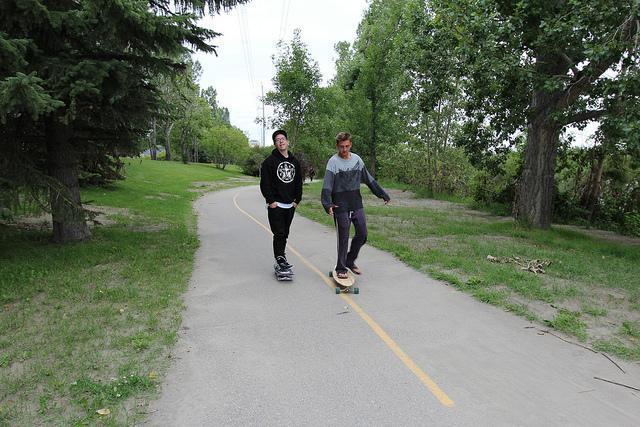How many people are riding skateboards on this street?
Give a very brief answer. 2. How many potholes are visible?
Give a very brief answer. 0. How many people can be seen?
Give a very brief answer. 2. How many white computer mice are in the image?
Give a very brief answer. 0. 